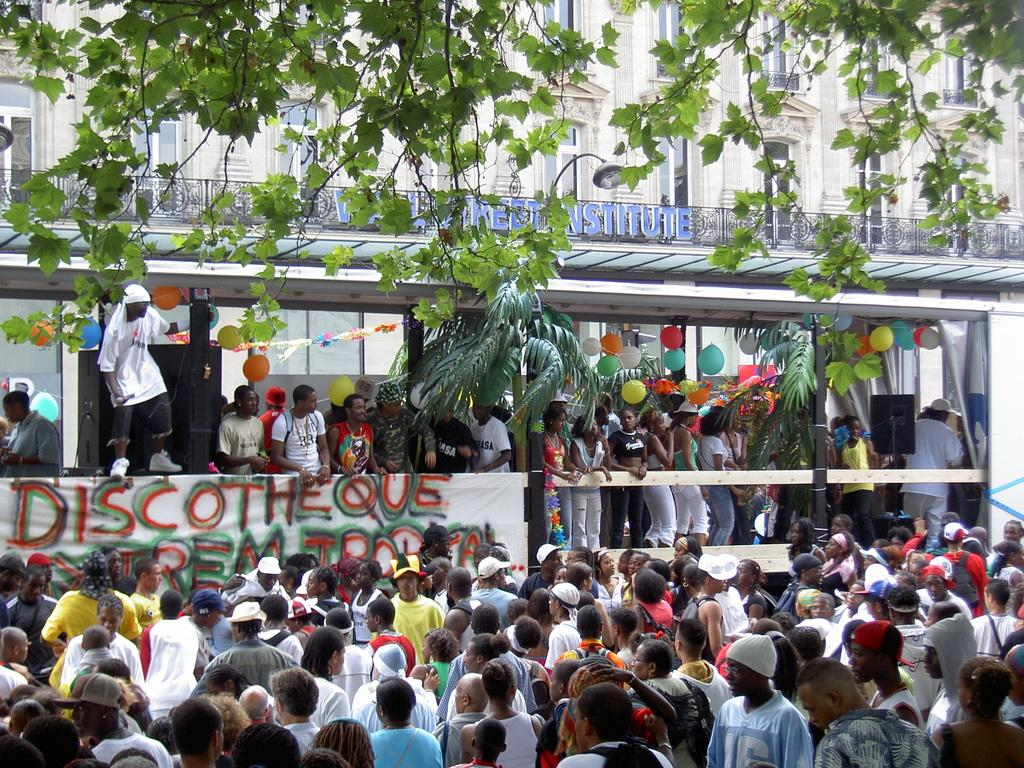What can be seen in the image? There are people standing in the image. What is visible in the background of the image? There is a building in the background of the image. What type of vegetation is visible at the top of the image? Leaves are visible at the top of the image. How many beans are being held by the girls in the image? There are no girls or beans present in the image. 